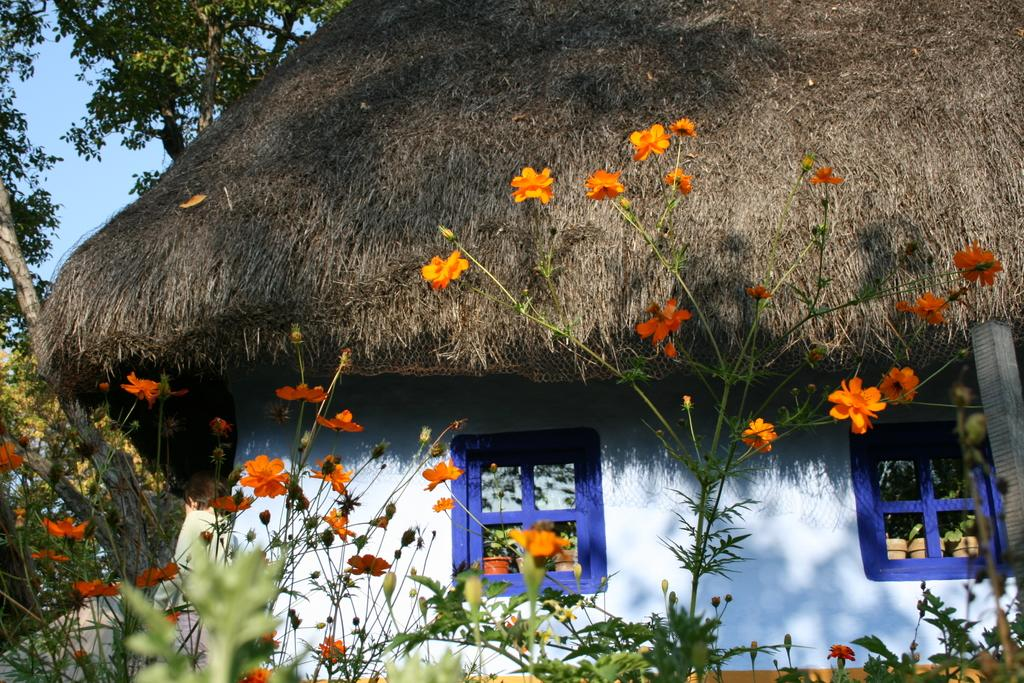What type of house is depicted in the image? There is a small house in the image. What color is the house? The house is white in color. What material is used for the roof of the house? The house has a straw roof. What can be seen growing near the house in the image? There is an orange flower plant in the front bottom side of the image. How many cats are sitting on the snow-covered roof of the house in the image? There are no cats or snow present in the image, and therefore no such activity can be observed. 